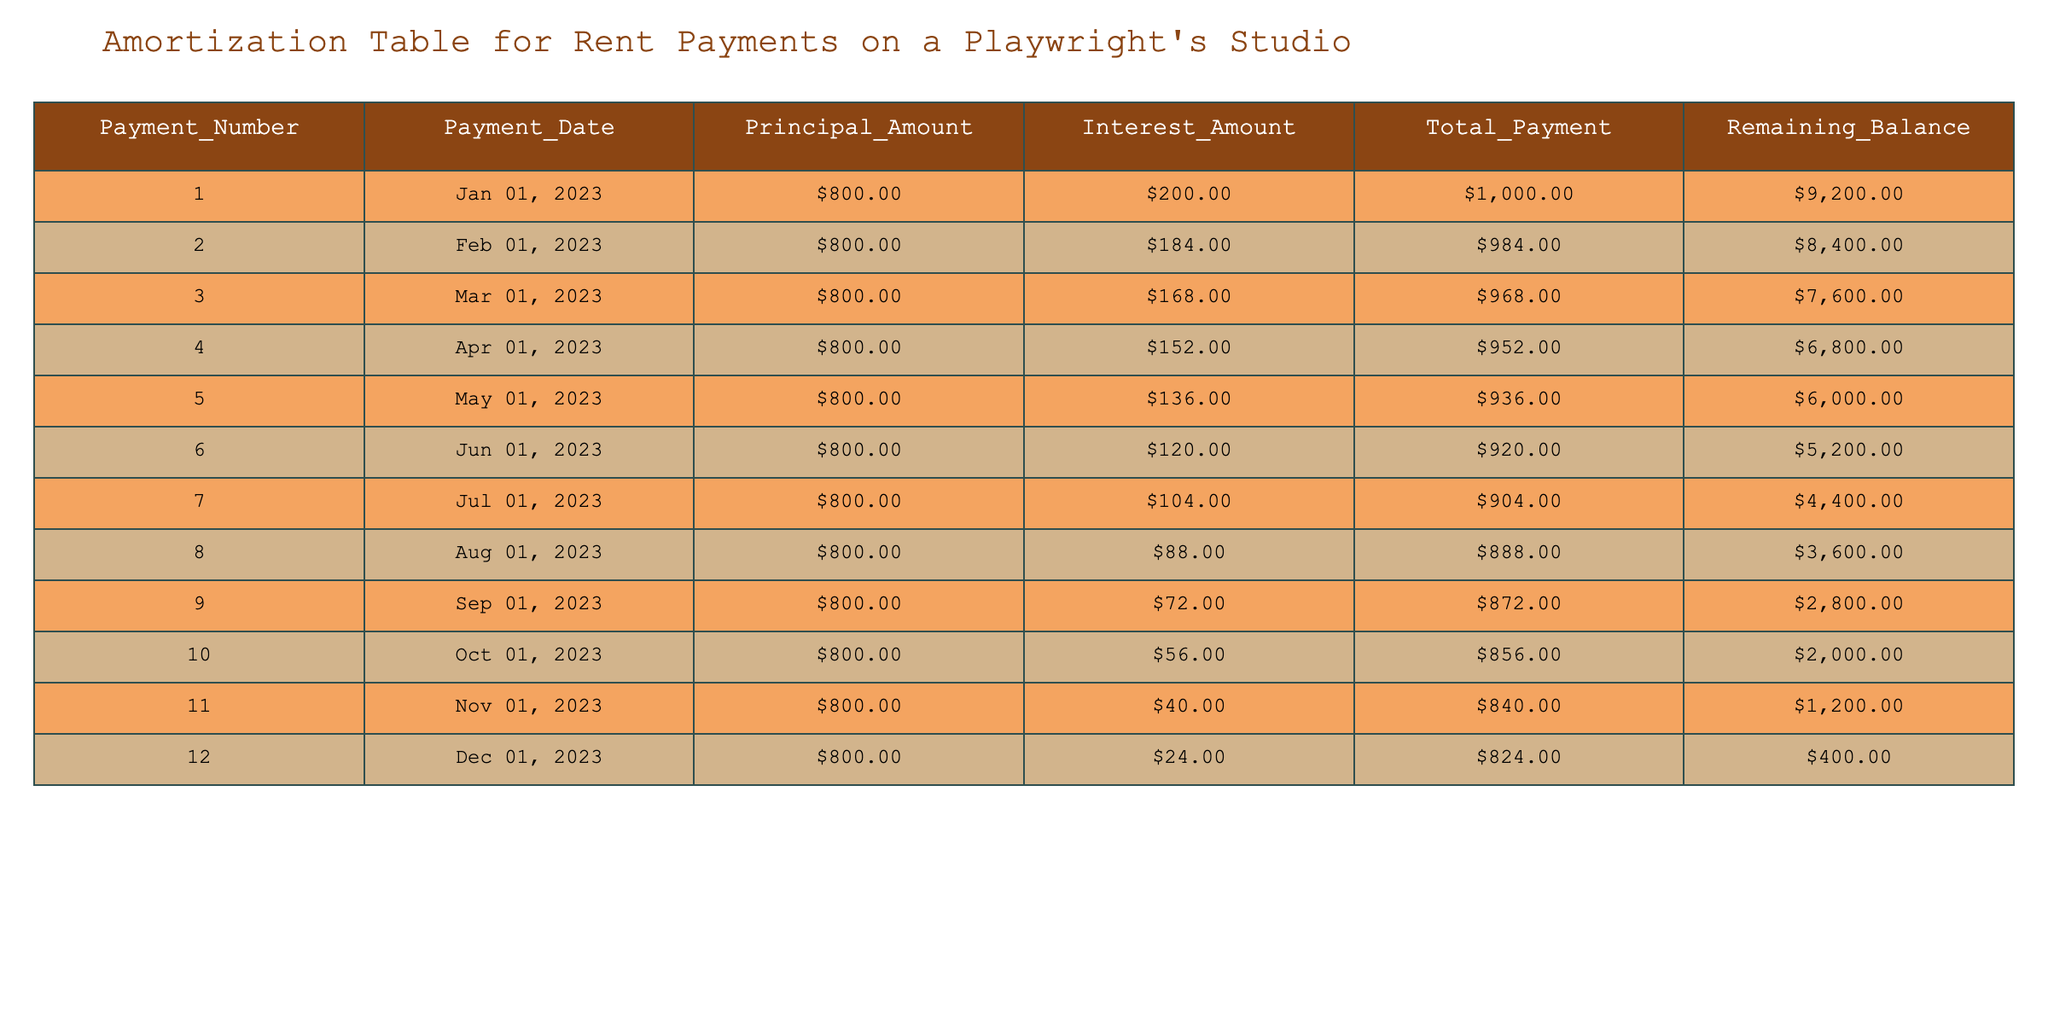What is the total payment amount for the first month's rent? The first month's rent is listed in the table under the Total_Payment column for Payment_Number 1. The amount is 1000.
Answer: 1000 What was the remaining balance after the fifth payment? To find the remaining balance after the fifth payment, look at the Remaining_Balance column for Payment_Number 5. The amount is 6000.
Answer: 6000 How much was the interest amount in the last month? The interest amount for the last payment is found in the Interest_Amount column for Payment_Number 12. The amount is 24.
Answer: 24 What is the difference between the principal amount of the first and last payment? The principal amounts are 800 for Payment_Number 1 and 800 for Payment_Number 12. The difference is 800 - 800 = 0.
Answer: 0 Was the total payment amount for the second month higher than that of the third month? The total payments for the second month (984) and third month (968) are compared. Since 984 is greater than 968, the statement is true.
Answer: Yes What is the average interest amount paid over the 12 months? The interest amounts from all 12 payments are summed: (200 + 184 + 168 + 152 + 136 + 120 + 104 + 88 + 72 + 56 + 40 + 24) = 1296. Dividing by 12 gives an average of 108.
Answer: 108 Which payment number had the lowest remaining balance? Checking the Remaining_Balance column, the lowest amount is 400 at Payment_Number 12. Therefore, Payment_Number 12 had the lowest remaining balance.
Answer: Payment_Number 12 What is the total of all principal payments made in the first half of the year? The principal payments for the first half (payments 1-6) are summed: 800 + 800 + 800 + 800 + 800 + 800 = 4800.
Answer: 4800 Which month saw the largest decrease in interest amount compared to the previous month? The interest amounts from month to month are compared to find the largest decrease: From 200 to 184 is a decrease of 16, and from 184 to 168 is a decrease of 16, continuing this way until the month with the largest decrease is identified which is from 104 to 88, a decrease of 16.
Answer: 16 